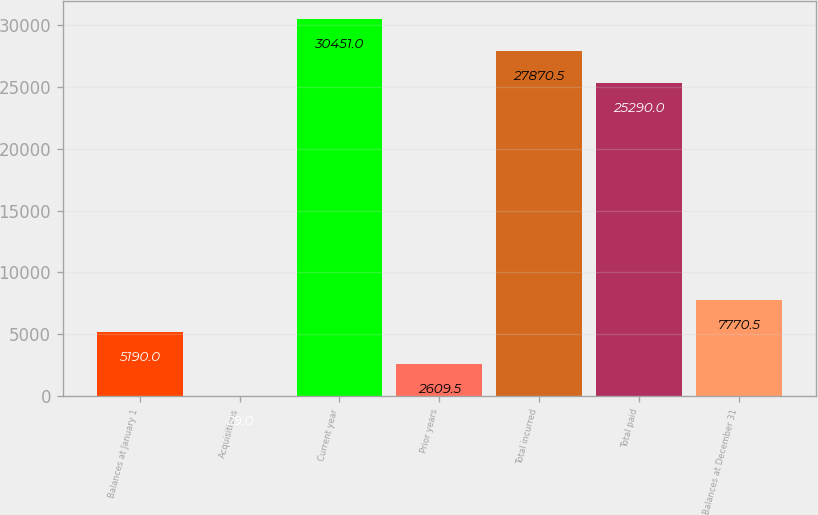<chart> <loc_0><loc_0><loc_500><loc_500><bar_chart><fcel>Balances at January 1<fcel>Acquisitions<fcel>Current year<fcel>Prior years<fcel>Total incurred<fcel>Total paid<fcel>Balances at December 31<nl><fcel>5190<fcel>29<fcel>30451<fcel>2609.5<fcel>27870.5<fcel>25290<fcel>7770.5<nl></chart> 